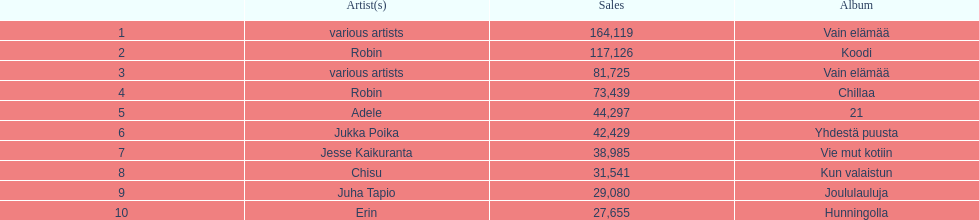Which was better selling, hunningolla or vain elamaa? Vain elämää. 